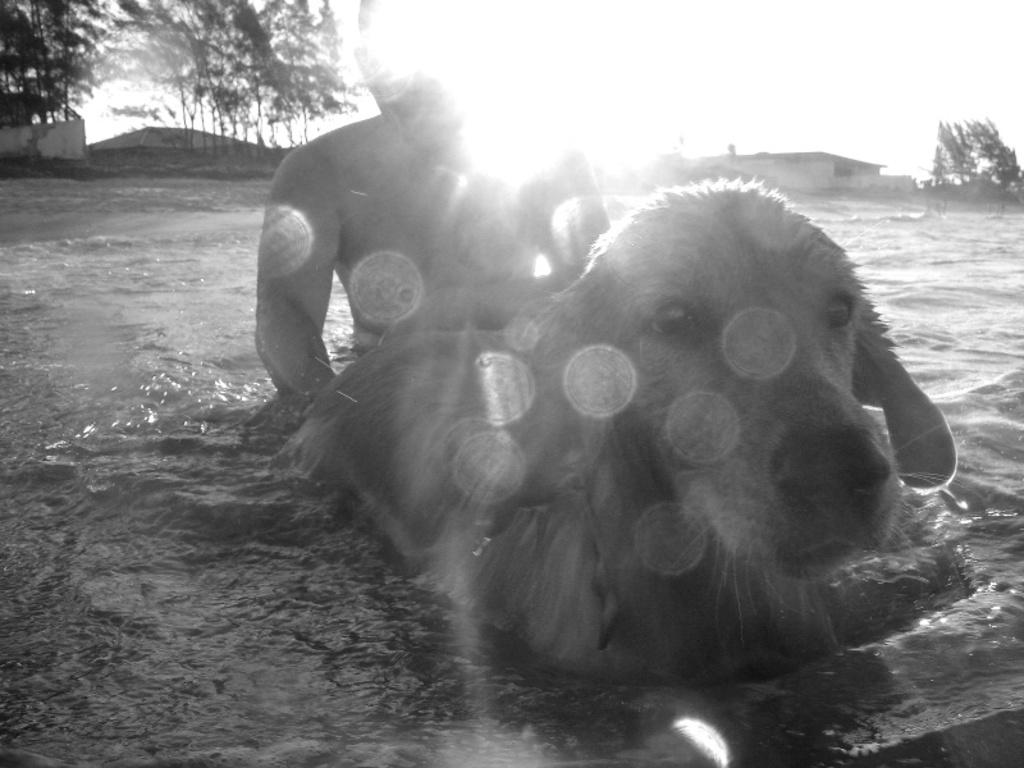What is the person in the image doing? The person is swimming in the water. What is the dog in the image doing? The dog is swimming in the water as well. What can be seen in the background of the image? There are buildings and trees in the background of the image. How does the person sneeze while swimming in the image? There is no indication in the image that the person is sneezing while swimming. 